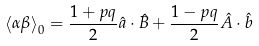Convert formula to latex. <formula><loc_0><loc_0><loc_500><loc_500>\left \langle \alpha \beta \right \rangle _ { 0 } = \frac { 1 + p q } { 2 } \hat { a } \cdot \hat { B } + \frac { 1 - p q } { 2 } \hat { A } \cdot \hat { b }</formula> 